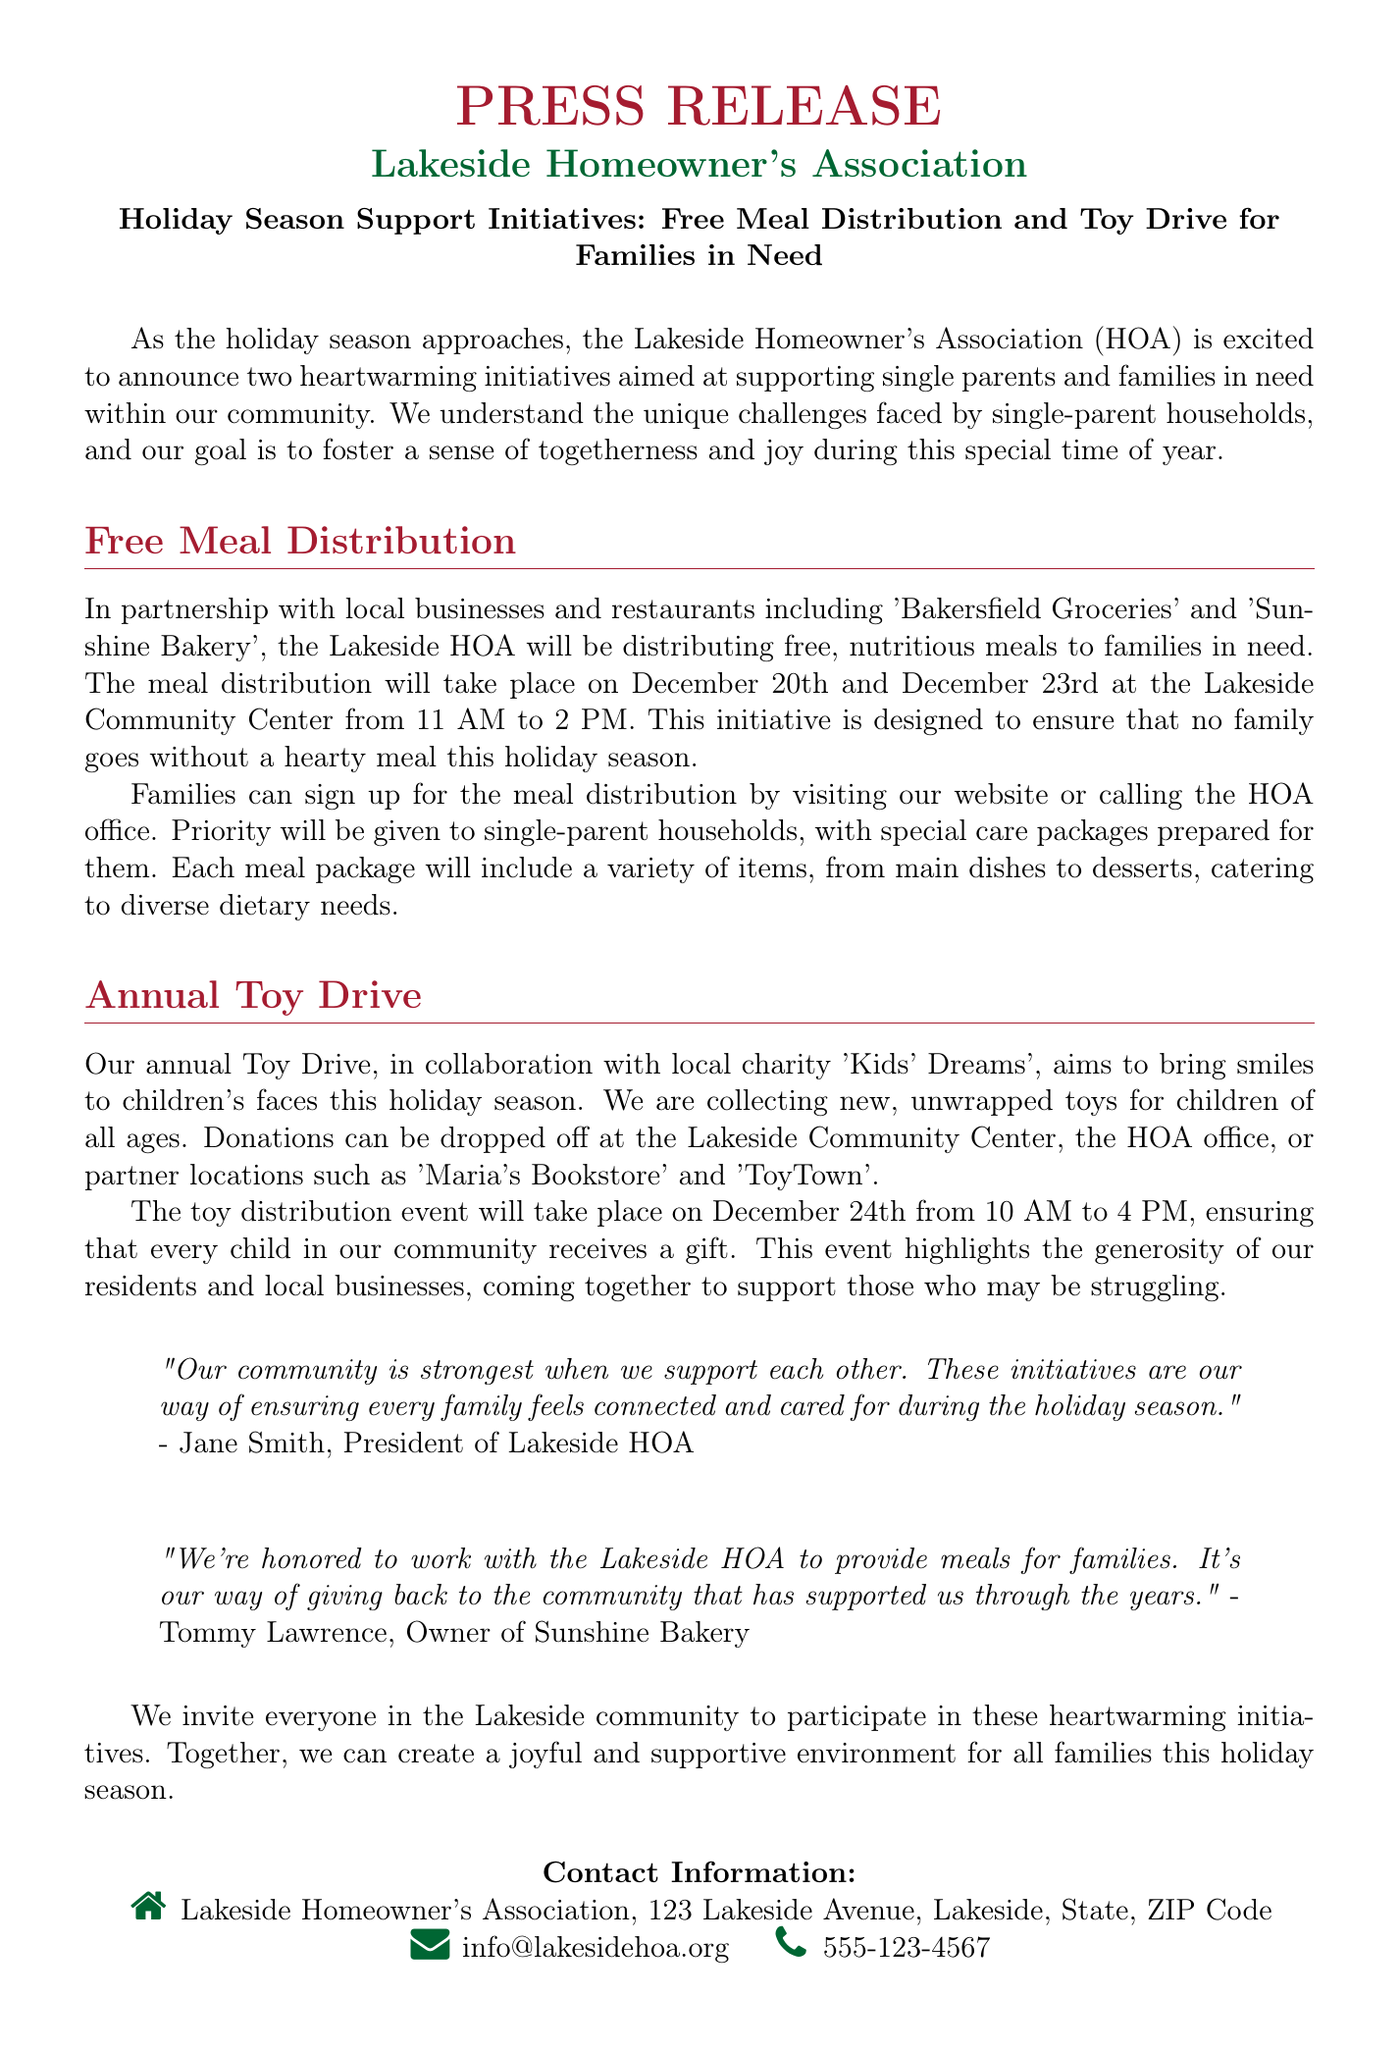What are the dates for the Free Meal Distribution? The document specifies that the Free Meal Distribution will take place on December 20th and December 23rd.
Answer: December 20th and December 23rd Who is the President of the Lakeside HOA? The document quotes Jane Smith as the President of the Lakeside HOA.
Answer: Jane Smith What is the location for the Toy Drive drop-off? The document lists multiple locations including Lakeside Community Center and partner locations like 'Maria's Bookstore' and 'ToyTown'.
Answer: Lakeside Community Center, Maria's Bookstore, ToyTown What time does the Toy distribution event start? According to the document, the Toy distribution event starts at 10 AM on December 24th.
Answer: 10 AM Which local business partnered with the HOA for the meal distribution? The document mentions 'Sunshine Bakery' as a partner for the meal distribution.
Answer: Sunshine Bakery What is the main aim of the Holiday Season Support Initiatives? The document states the goal is to support single parents and families in need in the community.
Answer: Support single parents and families in need How many hours is the Toy distribution event? The document notes that the Toy distribution event runs from 10 AM to 4 PM, making it 6 hours long.
Answer: 6 hours What type of meals will be distributed? The document highlights that the meals will be nutritious and cater to diverse dietary needs.
Answer: Nutritious meals 